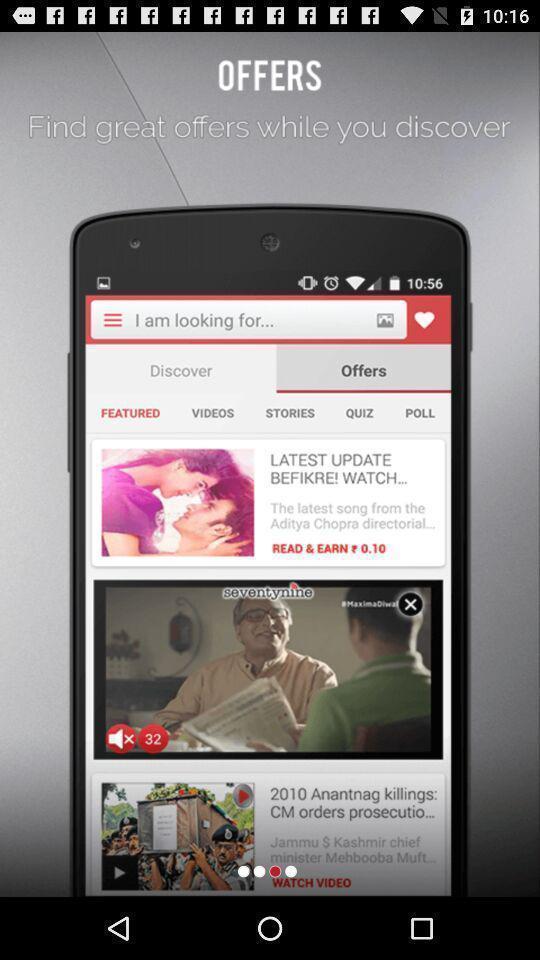Describe the content in this image. Welcome page. 